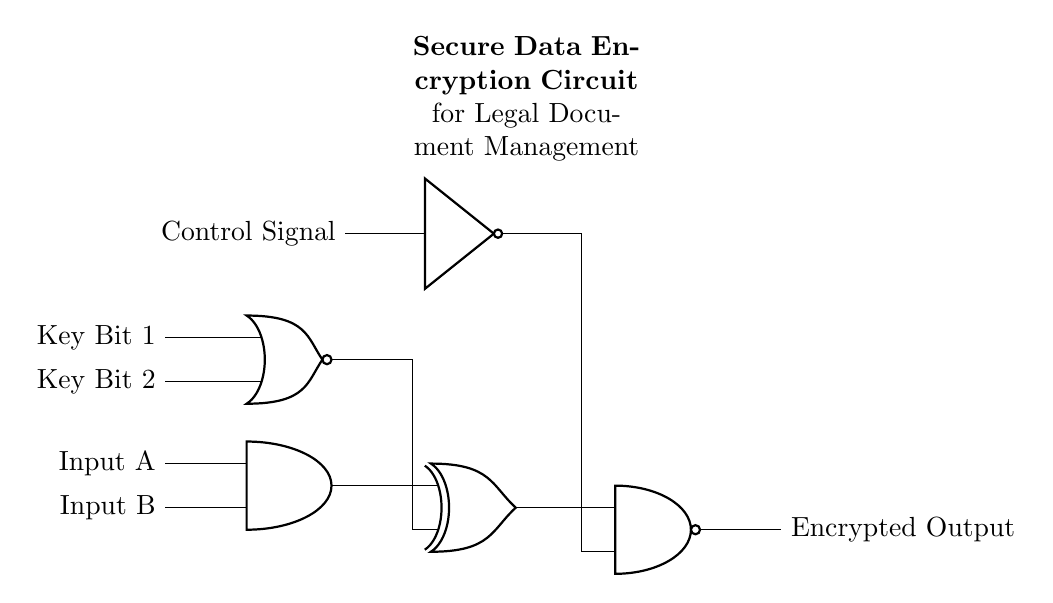What type of logic gate is shown at the beginning of the circuit? The circuit starts with an AND gate, indicated by the label and its standard symbol. This gate combines two input signals to create one output signal that is high only when both inputs are high.
Answer: AND gate How many inputs does the NAND gate have in this circuit? The NAND gate in the circuit has two inputs, as indicated by the number of lines connecting to it. Each line represents a different input to the gate.
Answer: Two What is the role of the NOT gate in this circuit? The NOT gate inverts the control signal, meaning that it takes an input signal and produces the opposite output. This is crucial for data encryption, potentially acting as a toggle based on conditions from the control signal.
Answer: Invert control signal What happens to the output if both Input A and Input B are low? If both inputs to the AND gate are low, then the output of the AND gate will also be low, which means the XNOR gate receives one low input. The output will depend on the other inputs, but it starts with a low signal.
Answer: Low output What operates the NOR gate in this design? The NOR gate is operated by two key bits, and it performs logical NOR operation on these two inputs. This means it will output high only when both key bits are low, which is essential for the encryption process.
Answer: Key Bit 1 and Key Bit 2 In this circuit, what is the final output label? The final output of this circuit is labeled as "Encrypted Output." This implies the output signal is the result of the encryption process from the prior logic gates combined and processed.
Answer: Encrypted Output 